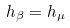<formula> <loc_0><loc_0><loc_500><loc_500>h _ { \beta } = h _ { \mu }</formula> 